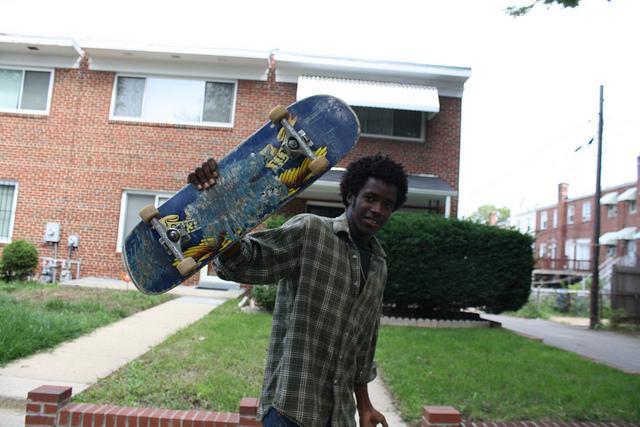How many blue lanterns are hanging on the left side of the banana bunches?
Give a very brief answer. 0. 